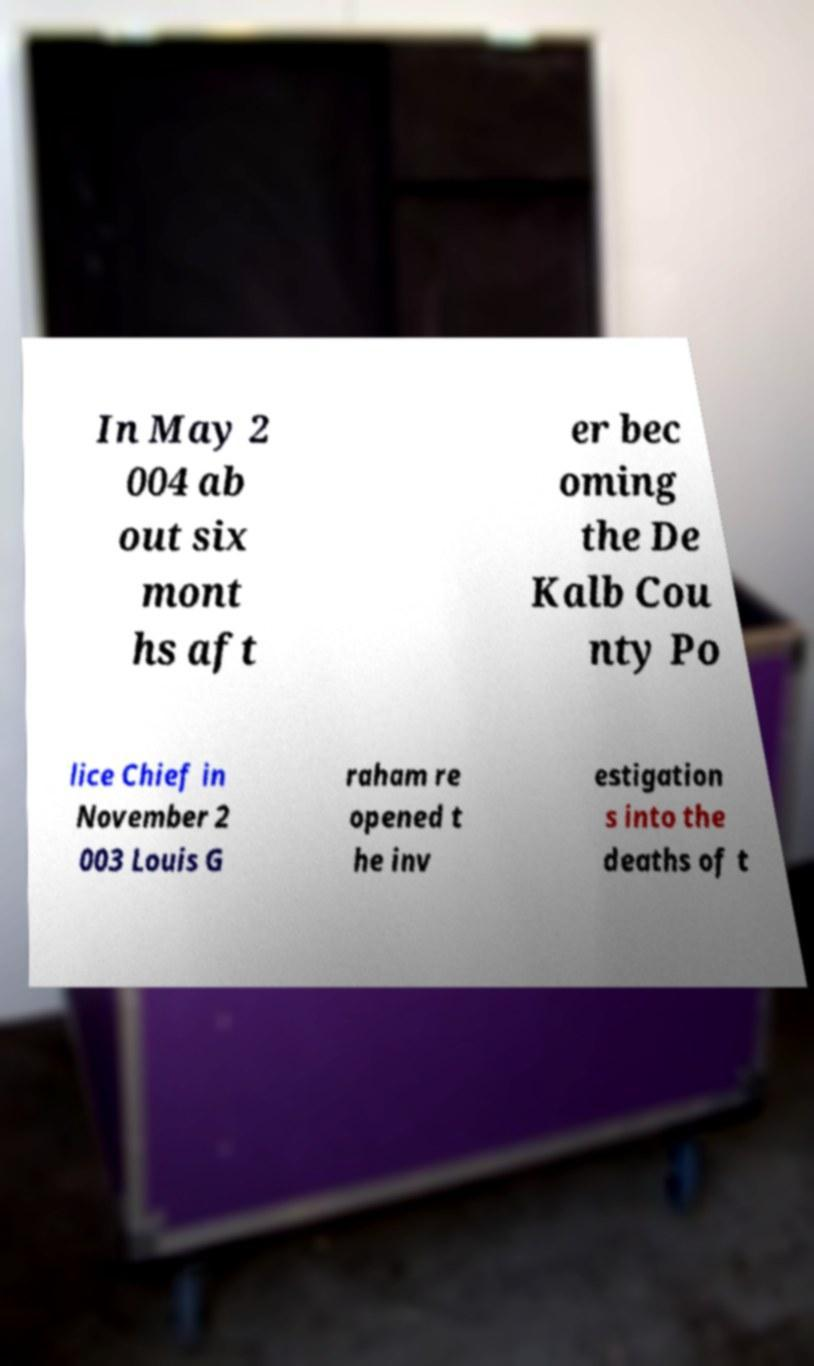Please identify and transcribe the text found in this image. In May 2 004 ab out six mont hs aft er bec oming the De Kalb Cou nty Po lice Chief in November 2 003 Louis G raham re opened t he inv estigation s into the deaths of t 